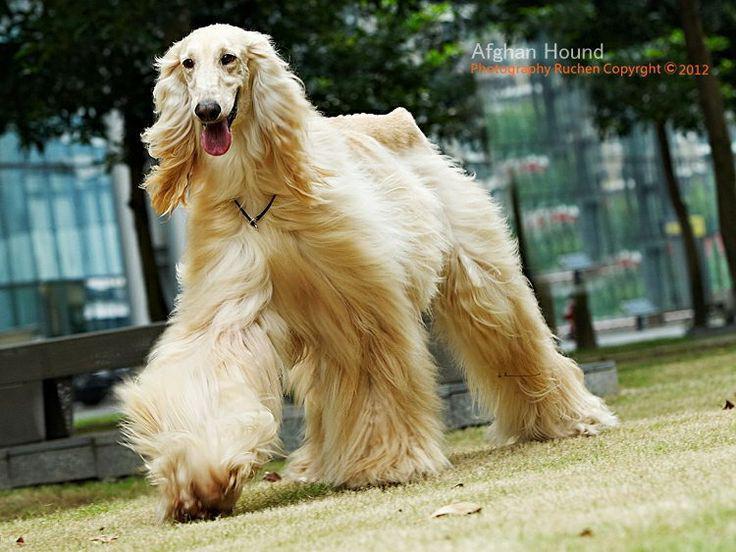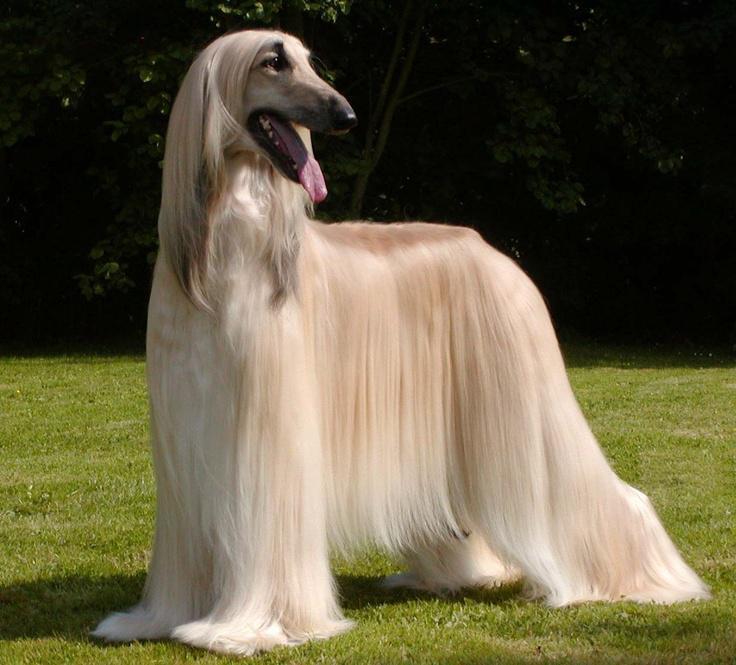The first image is the image on the left, the second image is the image on the right. Assess this claim about the two images: "The dog in the image on the left is taking strides as it walks outside.". Correct or not? Answer yes or no. Yes. The first image is the image on the left, the second image is the image on the right. For the images shown, is this caption "An image clearly shows a 'blond' long-haired hound that is on the grass but not standing." true? Answer yes or no. No. 